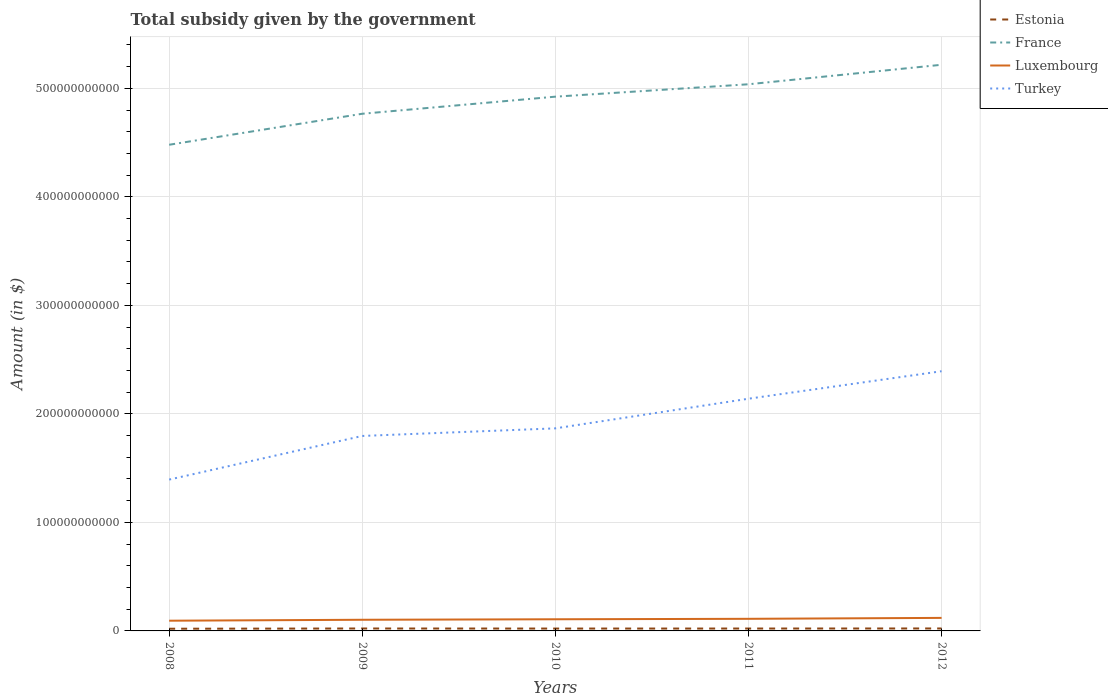How many different coloured lines are there?
Offer a terse response. 4. Does the line corresponding to Turkey intersect with the line corresponding to Luxembourg?
Your answer should be very brief. No. Across all years, what is the maximum total revenue collected by the government in France?
Your answer should be compact. 4.48e+11. What is the total total revenue collected by the government in Turkey in the graph?
Offer a terse response. -5.96e+1. What is the difference between the highest and the second highest total revenue collected by the government in France?
Make the answer very short. 7.37e+1. What is the difference between the highest and the lowest total revenue collected by the government in Turkey?
Keep it short and to the point. 2. What is the difference between two consecutive major ticks on the Y-axis?
Offer a very short reply. 1.00e+11. Are the values on the major ticks of Y-axis written in scientific E-notation?
Provide a succinct answer. No. How many legend labels are there?
Make the answer very short. 4. How are the legend labels stacked?
Your response must be concise. Vertical. What is the title of the graph?
Give a very brief answer. Total subsidy given by the government. What is the label or title of the X-axis?
Give a very brief answer. Years. What is the label or title of the Y-axis?
Provide a succinct answer. Amount (in $). What is the Amount (in $) of Estonia in 2008?
Offer a very short reply. 2.03e+09. What is the Amount (in $) in France in 2008?
Your answer should be compact. 4.48e+11. What is the Amount (in $) of Luxembourg in 2008?
Your answer should be compact. 9.41e+09. What is the Amount (in $) of Turkey in 2008?
Make the answer very short. 1.39e+11. What is the Amount (in $) in Estonia in 2009?
Ensure brevity in your answer.  2.23e+09. What is the Amount (in $) of France in 2009?
Ensure brevity in your answer.  4.77e+11. What is the Amount (in $) in Luxembourg in 2009?
Provide a succinct answer. 1.03e+1. What is the Amount (in $) in Turkey in 2009?
Offer a terse response. 1.80e+11. What is the Amount (in $) of Estonia in 2010?
Your answer should be very brief. 2.18e+09. What is the Amount (in $) in France in 2010?
Make the answer very short. 4.92e+11. What is the Amount (in $) in Luxembourg in 2010?
Your answer should be very brief. 1.07e+1. What is the Amount (in $) in Turkey in 2010?
Ensure brevity in your answer.  1.87e+11. What is the Amount (in $) in Estonia in 2011?
Provide a succinct answer. 2.20e+09. What is the Amount (in $) of France in 2011?
Provide a short and direct response. 5.04e+11. What is the Amount (in $) in Luxembourg in 2011?
Your answer should be very brief. 1.12e+1. What is the Amount (in $) of Turkey in 2011?
Your response must be concise. 2.14e+11. What is the Amount (in $) of Estonia in 2012?
Give a very brief answer. 2.27e+09. What is the Amount (in $) of France in 2012?
Your answer should be compact. 5.22e+11. What is the Amount (in $) of Luxembourg in 2012?
Your response must be concise. 1.20e+1. What is the Amount (in $) in Turkey in 2012?
Provide a succinct answer. 2.39e+11. Across all years, what is the maximum Amount (in $) in Estonia?
Your answer should be compact. 2.27e+09. Across all years, what is the maximum Amount (in $) in France?
Ensure brevity in your answer.  5.22e+11. Across all years, what is the maximum Amount (in $) in Luxembourg?
Offer a very short reply. 1.20e+1. Across all years, what is the maximum Amount (in $) of Turkey?
Offer a very short reply. 2.39e+11. Across all years, what is the minimum Amount (in $) in Estonia?
Keep it short and to the point. 2.03e+09. Across all years, what is the minimum Amount (in $) of France?
Offer a very short reply. 4.48e+11. Across all years, what is the minimum Amount (in $) of Luxembourg?
Ensure brevity in your answer.  9.41e+09. Across all years, what is the minimum Amount (in $) in Turkey?
Your answer should be compact. 1.39e+11. What is the total Amount (in $) of Estonia in the graph?
Provide a succinct answer. 1.09e+1. What is the total Amount (in $) of France in the graph?
Keep it short and to the point. 2.44e+12. What is the total Amount (in $) in Luxembourg in the graph?
Make the answer very short. 5.36e+1. What is the total Amount (in $) in Turkey in the graph?
Give a very brief answer. 9.59e+11. What is the difference between the Amount (in $) of Estonia in 2008 and that in 2009?
Ensure brevity in your answer.  -2.07e+08. What is the difference between the Amount (in $) in France in 2008 and that in 2009?
Provide a short and direct response. -2.86e+1. What is the difference between the Amount (in $) in Luxembourg in 2008 and that in 2009?
Ensure brevity in your answer.  -8.68e+08. What is the difference between the Amount (in $) of Turkey in 2008 and that in 2009?
Provide a succinct answer. -4.02e+1. What is the difference between the Amount (in $) of Estonia in 2008 and that in 2010?
Provide a short and direct response. -1.51e+08. What is the difference between the Amount (in $) in France in 2008 and that in 2010?
Ensure brevity in your answer.  -4.43e+1. What is the difference between the Amount (in $) of Luxembourg in 2008 and that in 2010?
Keep it short and to the point. -1.33e+09. What is the difference between the Amount (in $) in Turkey in 2008 and that in 2010?
Ensure brevity in your answer.  -4.72e+1. What is the difference between the Amount (in $) of Estonia in 2008 and that in 2011?
Give a very brief answer. -1.73e+08. What is the difference between the Amount (in $) of France in 2008 and that in 2011?
Your answer should be compact. -5.57e+1. What is the difference between the Amount (in $) in Luxembourg in 2008 and that in 2011?
Ensure brevity in your answer.  -1.75e+09. What is the difference between the Amount (in $) of Turkey in 2008 and that in 2011?
Your answer should be compact. -7.45e+1. What is the difference between the Amount (in $) in Estonia in 2008 and that in 2012?
Your response must be concise. -2.40e+08. What is the difference between the Amount (in $) in France in 2008 and that in 2012?
Offer a very short reply. -7.37e+1. What is the difference between the Amount (in $) of Luxembourg in 2008 and that in 2012?
Make the answer very short. -2.59e+09. What is the difference between the Amount (in $) in Turkey in 2008 and that in 2012?
Your answer should be very brief. -9.99e+1. What is the difference between the Amount (in $) of Estonia in 2009 and that in 2010?
Provide a short and direct response. 5.54e+07. What is the difference between the Amount (in $) of France in 2009 and that in 2010?
Offer a very short reply. -1.57e+1. What is the difference between the Amount (in $) in Luxembourg in 2009 and that in 2010?
Provide a short and direct response. -4.66e+08. What is the difference between the Amount (in $) of Turkey in 2009 and that in 2010?
Provide a short and direct response. -6.99e+09. What is the difference between the Amount (in $) in Estonia in 2009 and that in 2011?
Keep it short and to the point. 3.40e+07. What is the difference between the Amount (in $) of France in 2009 and that in 2011?
Give a very brief answer. -2.72e+1. What is the difference between the Amount (in $) of Luxembourg in 2009 and that in 2011?
Offer a very short reply. -8.83e+08. What is the difference between the Amount (in $) in Turkey in 2009 and that in 2011?
Offer a very short reply. -3.43e+1. What is the difference between the Amount (in $) of Estonia in 2009 and that in 2012?
Offer a terse response. -3.31e+07. What is the difference between the Amount (in $) of France in 2009 and that in 2012?
Give a very brief answer. -4.51e+1. What is the difference between the Amount (in $) in Luxembourg in 2009 and that in 2012?
Your answer should be compact. -1.73e+09. What is the difference between the Amount (in $) of Turkey in 2009 and that in 2012?
Keep it short and to the point. -5.96e+1. What is the difference between the Amount (in $) of Estonia in 2010 and that in 2011?
Ensure brevity in your answer.  -2.14e+07. What is the difference between the Amount (in $) of France in 2010 and that in 2011?
Offer a very short reply. -1.14e+1. What is the difference between the Amount (in $) of Luxembourg in 2010 and that in 2011?
Provide a short and direct response. -4.17e+08. What is the difference between the Amount (in $) in Turkey in 2010 and that in 2011?
Provide a succinct answer. -2.73e+1. What is the difference between the Amount (in $) in Estonia in 2010 and that in 2012?
Your answer should be compact. -8.85e+07. What is the difference between the Amount (in $) of France in 2010 and that in 2012?
Your answer should be very brief. -2.94e+1. What is the difference between the Amount (in $) of Luxembourg in 2010 and that in 2012?
Provide a succinct answer. -1.26e+09. What is the difference between the Amount (in $) of Turkey in 2010 and that in 2012?
Give a very brief answer. -5.27e+1. What is the difference between the Amount (in $) of Estonia in 2011 and that in 2012?
Your answer should be compact. -6.71e+07. What is the difference between the Amount (in $) in France in 2011 and that in 2012?
Provide a short and direct response. -1.80e+1. What is the difference between the Amount (in $) of Luxembourg in 2011 and that in 2012?
Your response must be concise. -8.42e+08. What is the difference between the Amount (in $) in Turkey in 2011 and that in 2012?
Keep it short and to the point. -2.53e+1. What is the difference between the Amount (in $) of Estonia in 2008 and the Amount (in $) of France in 2009?
Your answer should be very brief. -4.75e+11. What is the difference between the Amount (in $) in Estonia in 2008 and the Amount (in $) in Luxembourg in 2009?
Offer a very short reply. -8.25e+09. What is the difference between the Amount (in $) in Estonia in 2008 and the Amount (in $) in Turkey in 2009?
Your answer should be compact. -1.78e+11. What is the difference between the Amount (in $) in France in 2008 and the Amount (in $) in Luxembourg in 2009?
Your response must be concise. 4.38e+11. What is the difference between the Amount (in $) of France in 2008 and the Amount (in $) of Turkey in 2009?
Offer a very short reply. 2.68e+11. What is the difference between the Amount (in $) of Luxembourg in 2008 and the Amount (in $) of Turkey in 2009?
Offer a very short reply. -1.70e+11. What is the difference between the Amount (in $) in Estonia in 2008 and the Amount (in $) in France in 2010?
Provide a short and direct response. -4.90e+11. What is the difference between the Amount (in $) in Estonia in 2008 and the Amount (in $) in Luxembourg in 2010?
Provide a succinct answer. -8.72e+09. What is the difference between the Amount (in $) in Estonia in 2008 and the Amount (in $) in Turkey in 2010?
Give a very brief answer. -1.85e+11. What is the difference between the Amount (in $) in France in 2008 and the Amount (in $) in Luxembourg in 2010?
Offer a very short reply. 4.37e+11. What is the difference between the Amount (in $) of France in 2008 and the Amount (in $) of Turkey in 2010?
Your answer should be compact. 2.61e+11. What is the difference between the Amount (in $) in Luxembourg in 2008 and the Amount (in $) in Turkey in 2010?
Offer a terse response. -1.77e+11. What is the difference between the Amount (in $) of Estonia in 2008 and the Amount (in $) of France in 2011?
Your answer should be compact. -5.02e+11. What is the difference between the Amount (in $) in Estonia in 2008 and the Amount (in $) in Luxembourg in 2011?
Your response must be concise. -9.14e+09. What is the difference between the Amount (in $) of Estonia in 2008 and the Amount (in $) of Turkey in 2011?
Your answer should be very brief. -2.12e+11. What is the difference between the Amount (in $) of France in 2008 and the Amount (in $) of Luxembourg in 2011?
Offer a very short reply. 4.37e+11. What is the difference between the Amount (in $) in France in 2008 and the Amount (in $) in Turkey in 2011?
Ensure brevity in your answer.  2.34e+11. What is the difference between the Amount (in $) of Luxembourg in 2008 and the Amount (in $) of Turkey in 2011?
Provide a short and direct response. -2.05e+11. What is the difference between the Amount (in $) in Estonia in 2008 and the Amount (in $) in France in 2012?
Give a very brief answer. -5.20e+11. What is the difference between the Amount (in $) in Estonia in 2008 and the Amount (in $) in Luxembourg in 2012?
Your response must be concise. -9.98e+09. What is the difference between the Amount (in $) in Estonia in 2008 and the Amount (in $) in Turkey in 2012?
Ensure brevity in your answer.  -2.37e+11. What is the difference between the Amount (in $) in France in 2008 and the Amount (in $) in Luxembourg in 2012?
Offer a terse response. 4.36e+11. What is the difference between the Amount (in $) of France in 2008 and the Amount (in $) of Turkey in 2012?
Make the answer very short. 2.09e+11. What is the difference between the Amount (in $) in Luxembourg in 2008 and the Amount (in $) in Turkey in 2012?
Your answer should be very brief. -2.30e+11. What is the difference between the Amount (in $) in Estonia in 2009 and the Amount (in $) in France in 2010?
Keep it short and to the point. -4.90e+11. What is the difference between the Amount (in $) of Estonia in 2009 and the Amount (in $) of Luxembourg in 2010?
Offer a very short reply. -8.51e+09. What is the difference between the Amount (in $) in Estonia in 2009 and the Amount (in $) in Turkey in 2010?
Provide a short and direct response. -1.84e+11. What is the difference between the Amount (in $) in France in 2009 and the Amount (in $) in Luxembourg in 2010?
Your response must be concise. 4.66e+11. What is the difference between the Amount (in $) of France in 2009 and the Amount (in $) of Turkey in 2010?
Offer a very short reply. 2.90e+11. What is the difference between the Amount (in $) in Luxembourg in 2009 and the Amount (in $) in Turkey in 2010?
Ensure brevity in your answer.  -1.76e+11. What is the difference between the Amount (in $) of Estonia in 2009 and the Amount (in $) of France in 2011?
Your response must be concise. -5.02e+11. What is the difference between the Amount (in $) in Estonia in 2009 and the Amount (in $) in Luxembourg in 2011?
Offer a very short reply. -8.93e+09. What is the difference between the Amount (in $) of Estonia in 2009 and the Amount (in $) of Turkey in 2011?
Ensure brevity in your answer.  -2.12e+11. What is the difference between the Amount (in $) of France in 2009 and the Amount (in $) of Luxembourg in 2011?
Your answer should be very brief. 4.65e+11. What is the difference between the Amount (in $) in France in 2009 and the Amount (in $) in Turkey in 2011?
Make the answer very short. 2.63e+11. What is the difference between the Amount (in $) in Luxembourg in 2009 and the Amount (in $) in Turkey in 2011?
Ensure brevity in your answer.  -2.04e+11. What is the difference between the Amount (in $) in Estonia in 2009 and the Amount (in $) in France in 2012?
Offer a terse response. -5.19e+11. What is the difference between the Amount (in $) of Estonia in 2009 and the Amount (in $) of Luxembourg in 2012?
Your response must be concise. -9.77e+09. What is the difference between the Amount (in $) in Estonia in 2009 and the Amount (in $) in Turkey in 2012?
Give a very brief answer. -2.37e+11. What is the difference between the Amount (in $) in France in 2009 and the Amount (in $) in Luxembourg in 2012?
Your answer should be very brief. 4.65e+11. What is the difference between the Amount (in $) in France in 2009 and the Amount (in $) in Turkey in 2012?
Your answer should be very brief. 2.37e+11. What is the difference between the Amount (in $) in Luxembourg in 2009 and the Amount (in $) in Turkey in 2012?
Make the answer very short. -2.29e+11. What is the difference between the Amount (in $) in Estonia in 2010 and the Amount (in $) in France in 2011?
Provide a short and direct response. -5.02e+11. What is the difference between the Amount (in $) in Estonia in 2010 and the Amount (in $) in Luxembourg in 2011?
Offer a very short reply. -8.99e+09. What is the difference between the Amount (in $) in Estonia in 2010 and the Amount (in $) in Turkey in 2011?
Make the answer very short. -2.12e+11. What is the difference between the Amount (in $) in France in 2010 and the Amount (in $) in Luxembourg in 2011?
Provide a short and direct response. 4.81e+11. What is the difference between the Amount (in $) of France in 2010 and the Amount (in $) of Turkey in 2011?
Offer a very short reply. 2.78e+11. What is the difference between the Amount (in $) in Luxembourg in 2010 and the Amount (in $) in Turkey in 2011?
Give a very brief answer. -2.03e+11. What is the difference between the Amount (in $) in Estonia in 2010 and the Amount (in $) in France in 2012?
Ensure brevity in your answer.  -5.20e+11. What is the difference between the Amount (in $) in Estonia in 2010 and the Amount (in $) in Luxembourg in 2012?
Offer a terse response. -9.83e+09. What is the difference between the Amount (in $) of Estonia in 2010 and the Amount (in $) of Turkey in 2012?
Your response must be concise. -2.37e+11. What is the difference between the Amount (in $) in France in 2010 and the Amount (in $) in Luxembourg in 2012?
Offer a terse response. 4.80e+11. What is the difference between the Amount (in $) in France in 2010 and the Amount (in $) in Turkey in 2012?
Offer a terse response. 2.53e+11. What is the difference between the Amount (in $) of Luxembourg in 2010 and the Amount (in $) of Turkey in 2012?
Your response must be concise. -2.29e+11. What is the difference between the Amount (in $) of Estonia in 2011 and the Amount (in $) of France in 2012?
Offer a very short reply. -5.20e+11. What is the difference between the Amount (in $) in Estonia in 2011 and the Amount (in $) in Luxembourg in 2012?
Your answer should be very brief. -9.81e+09. What is the difference between the Amount (in $) of Estonia in 2011 and the Amount (in $) of Turkey in 2012?
Offer a very short reply. -2.37e+11. What is the difference between the Amount (in $) in France in 2011 and the Amount (in $) in Luxembourg in 2012?
Ensure brevity in your answer.  4.92e+11. What is the difference between the Amount (in $) of France in 2011 and the Amount (in $) of Turkey in 2012?
Ensure brevity in your answer.  2.64e+11. What is the difference between the Amount (in $) in Luxembourg in 2011 and the Amount (in $) in Turkey in 2012?
Give a very brief answer. -2.28e+11. What is the average Amount (in $) of Estonia per year?
Offer a terse response. 2.18e+09. What is the average Amount (in $) of France per year?
Give a very brief answer. 4.88e+11. What is the average Amount (in $) in Luxembourg per year?
Your answer should be very brief. 1.07e+1. What is the average Amount (in $) of Turkey per year?
Give a very brief answer. 1.92e+11. In the year 2008, what is the difference between the Amount (in $) of Estonia and Amount (in $) of France?
Offer a terse response. -4.46e+11. In the year 2008, what is the difference between the Amount (in $) of Estonia and Amount (in $) of Luxembourg?
Offer a terse response. -7.39e+09. In the year 2008, what is the difference between the Amount (in $) of Estonia and Amount (in $) of Turkey?
Provide a short and direct response. -1.37e+11. In the year 2008, what is the difference between the Amount (in $) in France and Amount (in $) in Luxembourg?
Ensure brevity in your answer.  4.39e+11. In the year 2008, what is the difference between the Amount (in $) in France and Amount (in $) in Turkey?
Your response must be concise. 3.09e+11. In the year 2008, what is the difference between the Amount (in $) of Luxembourg and Amount (in $) of Turkey?
Provide a succinct answer. -1.30e+11. In the year 2009, what is the difference between the Amount (in $) in Estonia and Amount (in $) in France?
Ensure brevity in your answer.  -4.74e+11. In the year 2009, what is the difference between the Amount (in $) of Estonia and Amount (in $) of Luxembourg?
Provide a short and direct response. -8.05e+09. In the year 2009, what is the difference between the Amount (in $) in Estonia and Amount (in $) in Turkey?
Provide a short and direct response. -1.77e+11. In the year 2009, what is the difference between the Amount (in $) of France and Amount (in $) of Luxembourg?
Ensure brevity in your answer.  4.66e+11. In the year 2009, what is the difference between the Amount (in $) in France and Amount (in $) in Turkey?
Offer a terse response. 2.97e+11. In the year 2009, what is the difference between the Amount (in $) in Luxembourg and Amount (in $) in Turkey?
Ensure brevity in your answer.  -1.69e+11. In the year 2010, what is the difference between the Amount (in $) of Estonia and Amount (in $) of France?
Ensure brevity in your answer.  -4.90e+11. In the year 2010, what is the difference between the Amount (in $) in Estonia and Amount (in $) in Luxembourg?
Keep it short and to the point. -8.57e+09. In the year 2010, what is the difference between the Amount (in $) of Estonia and Amount (in $) of Turkey?
Make the answer very short. -1.84e+11. In the year 2010, what is the difference between the Amount (in $) of France and Amount (in $) of Luxembourg?
Provide a succinct answer. 4.82e+11. In the year 2010, what is the difference between the Amount (in $) of France and Amount (in $) of Turkey?
Offer a very short reply. 3.06e+11. In the year 2010, what is the difference between the Amount (in $) of Luxembourg and Amount (in $) of Turkey?
Keep it short and to the point. -1.76e+11. In the year 2011, what is the difference between the Amount (in $) of Estonia and Amount (in $) of France?
Ensure brevity in your answer.  -5.02e+11. In the year 2011, what is the difference between the Amount (in $) in Estonia and Amount (in $) in Luxembourg?
Make the answer very short. -8.96e+09. In the year 2011, what is the difference between the Amount (in $) of Estonia and Amount (in $) of Turkey?
Ensure brevity in your answer.  -2.12e+11. In the year 2011, what is the difference between the Amount (in $) in France and Amount (in $) in Luxembourg?
Ensure brevity in your answer.  4.93e+11. In the year 2011, what is the difference between the Amount (in $) of France and Amount (in $) of Turkey?
Give a very brief answer. 2.90e+11. In the year 2011, what is the difference between the Amount (in $) of Luxembourg and Amount (in $) of Turkey?
Keep it short and to the point. -2.03e+11. In the year 2012, what is the difference between the Amount (in $) in Estonia and Amount (in $) in France?
Offer a very short reply. -5.19e+11. In the year 2012, what is the difference between the Amount (in $) in Estonia and Amount (in $) in Luxembourg?
Offer a very short reply. -9.74e+09. In the year 2012, what is the difference between the Amount (in $) in Estonia and Amount (in $) in Turkey?
Give a very brief answer. -2.37e+11. In the year 2012, what is the difference between the Amount (in $) in France and Amount (in $) in Luxembourg?
Offer a very short reply. 5.10e+11. In the year 2012, what is the difference between the Amount (in $) of France and Amount (in $) of Turkey?
Provide a succinct answer. 2.82e+11. In the year 2012, what is the difference between the Amount (in $) in Luxembourg and Amount (in $) in Turkey?
Provide a succinct answer. -2.27e+11. What is the ratio of the Amount (in $) in Estonia in 2008 to that in 2009?
Your answer should be very brief. 0.91. What is the ratio of the Amount (in $) in France in 2008 to that in 2009?
Provide a short and direct response. 0.94. What is the ratio of the Amount (in $) in Luxembourg in 2008 to that in 2009?
Give a very brief answer. 0.92. What is the ratio of the Amount (in $) of Turkey in 2008 to that in 2009?
Your response must be concise. 0.78. What is the ratio of the Amount (in $) in Estonia in 2008 to that in 2010?
Provide a short and direct response. 0.93. What is the ratio of the Amount (in $) of France in 2008 to that in 2010?
Offer a terse response. 0.91. What is the ratio of the Amount (in $) in Luxembourg in 2008 to that in 2010?
Provide a short and direct response. 0.88. What is the ratio of the Amount (in $) in Turkey in 2008 to that in 2010?
Ensure brevity in your answer.  0.75. What is the ratio of the Amount (in $) of Estonia in 2008 to that in 2011?
Offer a terse response. 0.92. What is the ratio of the Amount (in $) of France in 2008 to that in 2011?
Ensure brevity in your answer.  0.89. What is the ratio of the Amount (in $) of Luxembourg in 2008 to that in 2011?
Ensure brevity in your answer.  0.84. What is the ratio of the Amount (in $) in Turkey in 2008 to that in 2011?
Give a very brief answer. 0.65. What is the ratio of the Amount (in $) in Estonia in 2008 to that in 2012?
Offer a very short reply. 0.89. What is the ratio of the Amount (in $) of France in 2008 to that in 2012?
Ensure brevity in your answer.  0.86. What is the ratio of the Amount (in $) in Luxembourg in 2008 to that in 2012?
Provide a short and direct response. 0.78. What is the ratio of the Amount (in $) in Turkey in 2008 to that in 2012?
Provide a succinct answer. 0.58. What is the ratio of the Amount (in $) in Estonia in 2009 to that in 2010?
Provide a short and direct response. 1.03. What is the ratio of the Amount (in $) of France in 2009 to that in 2010?
Keep it short and to the point. 0.97. What is the ratio of the Amount (in $) of Luxembourg in 2009 to that in 2010?
Your answer should be very brief. 0.96. What is the ratio of the Amount (in $) of Turkey in 2009 to that in 2010?
Your response must be concise. 0.96. What is the ratio of the Amount (in $) of Estonia in 2009 to that in 2011?
Ensure brevity in your answer.  1.02. What is the ratio of the Amount (in $) in France in 2009 to that in 2011?
Provide a succinct answer. 0.95. What is the ratio of the Amount (in $) in Luxembourg in 2009 to that in 2011?
Provide a succinct answer. 0.92. What is the ratio of the Amount (in $) of Turkey in 2009 to that in 2011?
Make the answer very short. 0.84. What is the ratio of the Amount (in $) in Estonia in 2009 to that in 2012?
Your answer should be compact. 0.99. What is the ratio of the Amount (in $) in France in 2009 to that in 2012?
Keep it short and to the point. 0.91. What is the ratio of the Amount (in $) in Luxembourg in 2009 to that in 2012?
Make the answer very short. 0.86. What is the ratio of the Amount (in $) of Turkey in 2009 to that in 2012?
Give a very brief answer. 0.75. What is the ratio of the Amount (in $) in Estonia in 2010 to that in 2011?
Your answer should be compact. 0.99. What is the ratio of the Amount (in $) in France in 2010 to that in 2011?
Offer a very short reply. 0.98. What is the ratio of the Amount (in $) in Luxembourg in 2010 to that in 2011?
Offer a very short reply. 0.96. What is the ratio of the Amount (in $) in Turkey in 2010 to that in 2011?
Provide a succinct answer. 0.87. What is the ratio of the Amount (in $) in Estonia in 2010 to that in 2012?
Offer a terse response. 0.96. What is the ratio of the Amount (in $) in France in 2010 to that in 2012?
Your response must be concise. 0.94. What is the ratio of the Amount (in $) of Luxembourg in 2010 to that in 2012?
Provide a succinct answer. 0.9. What is the ratio of the Amount (in $) in Turkey in 2010 to that in 2012?
Ensure brevity in your answer.  0.78. What is the ratio of the Amount (in $) in Estonia in 2011 to that in 2012?
Your response must be concise. 0.97. What is the ratio of the Amount (in $) of France in 2011 to that in 2012?
Provide a succinct answer. 0.97. What is the ratio of the Amount (in $) in Luxembourg in 2011 to that in 2012?
Ensure brevity in your answer.  0.93. What is the ratio of the Amount (in $) in Turkey in 2011 to that in 2012?
Give a very brief answer. 0.89. What is the difference between the highest and the second highest Amount (in $) in Estonia?
Your response must be concise. 3.31e+07. What is the difference between the highest and the second highest Amount (in $) of France?
Provide a short and direct response. 1.80e+1. What is the difference between the highest and the second highest Amount (in $) of Luxembourg?
Make the answer very short. 8.42e+08. What is the difference between the highest and the second highest Amount (in $) in Turkey?
Your response must be concise. 2.53e+1. What is the difference between the highest and the lowest Amount (in $) in Estonia?
Provide a short and direct response. 2.40e+08. What is the difference between the highest and the lowest Amount (in $) in France?
Offer a terse response. 7.37e+1. What is the difference between the highest and the lowest Amount (in $) of Luxembourg?
Offer a very short reply. 2.59e+09. What is the difference between the highest and the lowest Amount (in $) of Turkey?
Ensure brevity in your answer.  9.99e+1. 